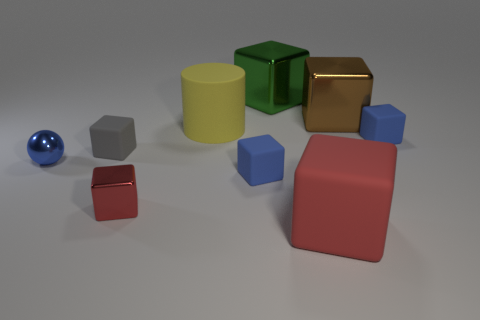Subtract 2 cubes. How many cubes are left? 5 Subtract all brown cubes. How many cubes are left? 6 Subtract all large red blocks. How many blocks are left? 6 Subtract all gray cubes. Subtract all purple cylinders. How many cubes are left? 6 Subtract all blocks. How many objects are left? 2 Add 3 large yellow matte objects. How many large yellow matte objects exist? 4 Subtract 1 gray blocks. How many objects are left? 8 Subtract all tiny cyan rubber cylinders. Subtract all large cylinders. How many objects are left? 8 Add 7 tiny blue balls. How many tiny blue balls are left? 8 